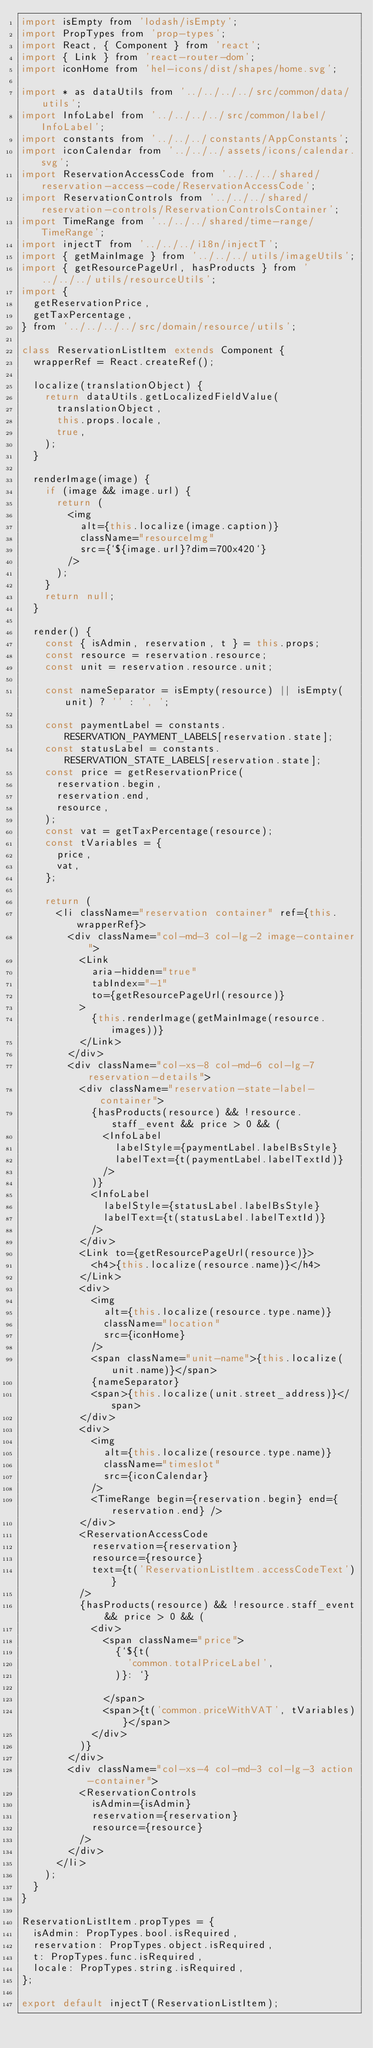Convert code to text. <code><loc_0><loc_0><loc_500><loc_500><_JavaScript_>import isEmpty from 'lodash/isEmpty';
import PropTypes from 'prop-types';
import React, { Component } from 'react';
import { Link } from 'react-router-dom';
import iconHome from 'hel-icons/dist/shapes/home.svg';

import * as dataUtils from '../../../../src/common/data/utils';
import InfoLabel from '../../../../src/common/label/InfoLabel';
import constants from '../../../constants/AppConstants';
import iconCalendar from '../../../assets/icons/calendar.svg';
import ReservationAccessCode from '../../../shared/reservation-access-code/ReservationAccessCode';
import ReservationControls from '../../../shared/reservation-controls/ReservationControlsContainer';
import TimeRange from '../../../shared/time-range/TimeRange';
import injectT from '../../../i18n/injectT';
import { getMainImage } from '../../../utils/imageUtils';
import { getResourcePageUrl, hasProducts } from '../../../utils/resourceUtils';
import {
  getReservationPrice,
  getTaxPercentage,
} from '../../../../src/domain/resource/utils';

class ReservationListItem extends Component {
  wrapperRef = React.createRef();

  localize(translationObject) {
    return dataUtils.getLocalizedFieldValue(
      translationObject,
      this.props.locale,
      true,
    );
  }

  renderImage(image) {
    if (image && image.url) {
      return (
        <img
          alt={this.localize(image.caption)}
          className="resourceImg"
          src={`${image.url}?dim=700x420`}
        />
      );
    }
    return null;
  }

  render() {
    const { isAdmin, reservation, t } = this.props;
    const resource = reservation.resource;
    const unit = reservation.resource.unit;

    const nameSeparator = isEmpty(resource) || isEmpty(unit) ? '' : ', ';

    const paymentLabel = constants.RESERVATION_PAYMENT_LABELS[reservation.state];
    const statusLabel = constants.RESERVATION_STATE_LABELS[reservation.state];
    const price = getReservationPrice(
      reservation.begin,
      reservation.end,
      resource,
    );
    const vat = getTaxPercentage(resource);
    const tVariables = {
      price,
      vat,
    };

    return (
      <li className="reservation container" ref={this.wrapperRef}>
        <div className="col-md-3 col-lg-2 image-container">
          <Link
            aria-hidden="true"
            tabIndex="-1"
            to={getResourcePageUrl(resource)}
          >
            {this.renderImage(getMainImage(resource.images))}
          </Link>
        </div>
        <div className="col-xs-8 col-md-6 col-lg-7 reservation-details">
          <div className="reservation-state-label-container">
            {hasProducts(resource) && !resource.staff_event && price > 0 && (
              <InfoLabel
                labelStyle={paymentLabel.labelBsStyle}
                labelText={t(paymentLabel.labelTextId)}
              />
            )}
            <InfoLabel
              labelStyle={statusLabel.labelBsStyle}
              labelText={t(statusLabel.labelTextId)}
            />
          </div>
          <Link to={getResourcePageUrl(resource)}>
            <h4>{this.localize(resource.name)}</h4>
          </Link>
          <div>
            <img
              alt={this.localize(resource.type.name)}
              className="location"
              src={iconHome}
            />
            <span className="unit-name">{this.localize(unit.name)}</span>
            {nameSeparator}
            <span>{this.localize(unit.street_address)}</span>
          </div>
          <div>
            <img
              alt={this.localize(resource.type.name)}
              className="timeslot"
              src={iconCalendar}
            />
            <TimeRange begin={reservation.begin} end={reservation.end} />
          </div>
          <ReservationAccessCode
            reservation={reservation}
            resource={resource}
            text={t('ReservationListItem.accessCodeText')}
          />
          {hasProducts(resource) && !resource.staff_event && price > 0 && (
            <div>
              <span className="price">
                {`${t(
                  'common.totalPriceLabel',
                )}: `}

              </span>
              <span>{t('common.priceWithVAT', tVariables)}</span>
            </div>
          )}
        </div>
        <div className="col-xs-4 col-md-3 col-lg-3 action-container">
          <ReservationControls
            isAdmin={isAdmin}
            reservation={reservation}
            resource={resource}
          />
        </div>
      </li>
    );
  }
}

ReservationListItem.propTypes = {
  isAdmin: PropTypes.bool.isRequired,
  reservation: PropTypes.object.isRequired,
  t: PropTypes.func.isRequired,
  locale: PropTypes.string.isRequired,
};

export default injectT(ReservationListItem);
</code> 